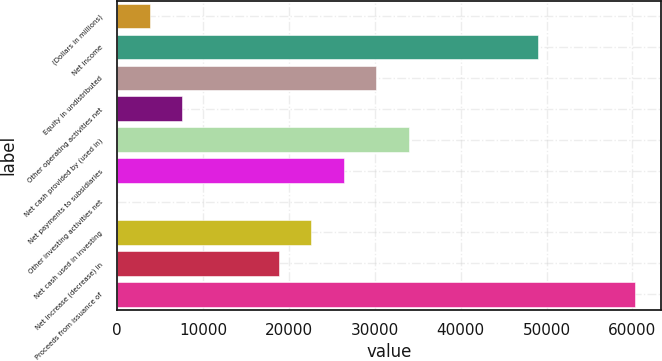<chart> <loc_0><loc_0><loc_500><loc_500><bar_chart><fcel>(Dollars in millions)<fcel>Net income<fcel>Equity in undistributed<fcel>Other operating activities net<fcel>Net cash provided by (used in)<fcel>Net payments to subsidiaries<fcel>Other investing activities net<fcel>Net cash used in investing<fcel>Net increase (decrease) in<fcel>Proceeds from issuance of<nl><fcel>3771.3<fcel>49014.9<fcel>30163.4<fcel>7541.6<fcel>33933.7<fcel>26393.1<fcel>1<fcel>22622.8<fcel>18852.5<fcel>60325.8<nl></chart> 